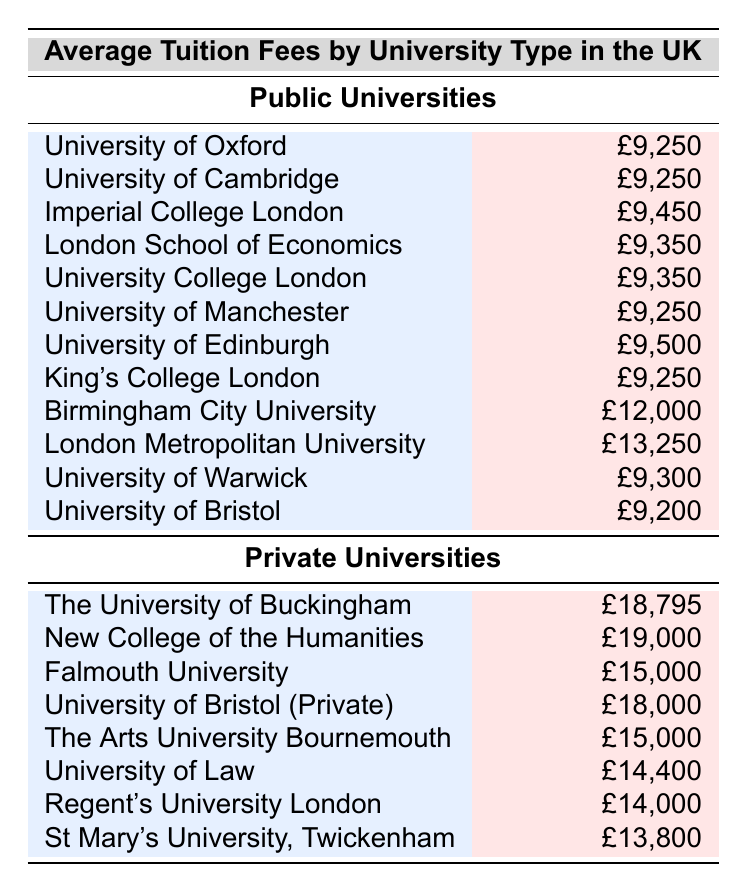What is the average tuition fee for public universities? The average tuition fees listed for public universities are: £9,250, £9,250, £9,450, £9,350, £9,350, £9,250, £9,500, £9,250, £12,000, £13,250, £9,300, and £9,200. Summing these values gives £111,200. There are 12 public universities, so the average is £111,200 / 12 = £9,266.67, rounded to £9,267.
Answer: £9,267 What is the highest average tuition fee among private universities? The average tuition fees listed for private universities are: £18,795, £19,000, £15,000, £18,000, £15,000, £14,400, £14,000, and £13,800. The highest fee in this list is £19,000.
Answer: £19,000 Is the average tuition fee of University College London higher than that of King's College London? The average tuition fee for University College London is £9,350, and for King's College London it is £9,250. Since £9,350 is greater than £9,250, the statement is true.
Answer: Yes Which university type has a lower average tuition fee? To find the answer, we need the averages of both types: the public universities average is £9,267, and the private universities average can be calculated by summing £18,795, £19,000, £15,000, £18,000, £15,000, £14,400, £14,000, and £13,800 (which totals £127,995), divided by 8 private universities gives an average of £15,999.375, rounded to £16,000. Since £9,267 is lower than £16,000, public universities have lower average tuition fees.
Answer: Public universities What is the difference in average tuition fees between the highest and lowest public university fees? The highest average tuition fee among public universities is £13,250 (London Metropolitan University), and the lowest is £9,200 (University of Bristol). The difference is £13,250 - £9,200 = £4,050.
Answer: £4,050 Are there any private universities with lower tuition fees than the highest public university fee? The highest public university tuition fee is £13,250. The private universities’ fees are £18,795, £19,000, £15,000, £18,000, £15,000, £14,400, £14,000, and £13,800. All private universities have higher tuition fees than £13,250.
Answer: No Which university has the second highest tuition fee among all universities? First, we list the tuition fees from highest to lowest: £19,000, £18,795, £18,000, £18795, £15,000, £15,000, £14,400, £14,000, £13,800, £13,250, £12,000, £9,500, £9,450, £9,350, £9,350, £9,300, £9,250, £9,250, and £9,200. The second highest in this list is £18,795, associated with The University of Buckingham.
Answer: The University of Buckingham How many universities have an average tuition fee over £15,000? Looking at the private universities, their fees are £18,795, £19,000, £18,000, £15,000, which are four fees over £15,000. Hence, there are four universities.
Answer: 4 What is the average tuition fee of the University of Bristol compared to that of the University of Edinburgh? The University of Bristol has an average tuition fee of £9,200, while the University of Edinburgh has £9,500. Since £9,500 is greater than £9,200, the average fee of the University of Edinburgh is higher.
Answer: Higher 